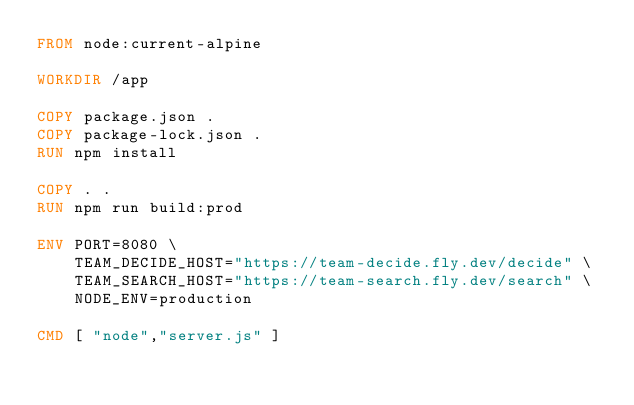Convert code to text. <code><loc_0><loc_0><loc_500><loc_500><_Dockerfile_>FROM node:current-alpine

WORKDIR /app

COPY package.json .
COPY package-lock.json .
RUN npm install

COPY . .
RUN npm run build:prod

ENV PORT=8080 \
    TEAM_DECIDE_HOST="https://team-decide.fly.dev/decide" \
    TEAM_SEARCH_HOST="https://team-search.fly.dev/search" \
    NODE_ENV=production

CMD [ "node","server.js" ]</code> 